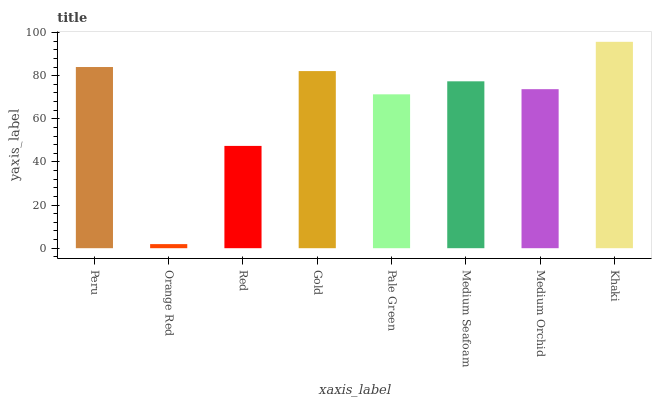Is Orange Red the minimum?
Answer yes or no. Yes. Is Khaki the maximum?
Answer yes or no. Yes. Is Red the minimum?
Answer yes or no. No. Is Red the maximum?
Answer yes or no. No. Is Red greater than Orange Red?
Answer yes or no. Yes. Is Orange Red less than Red?
Answer yes or no. Yes. Is Orange Red greater than Red?
Answer yes or no. No. Is Red less than Orange Red?
Answer yes or no. No. Is Medium Seafoam the high median?
Answer yes or no. Yes. Is Medium Orchid the low median?
Answer yes or no. Yes. Is Peru the high median?
Answer yes or no. No. Is Gold the low median?
Answer yes or no. No. 